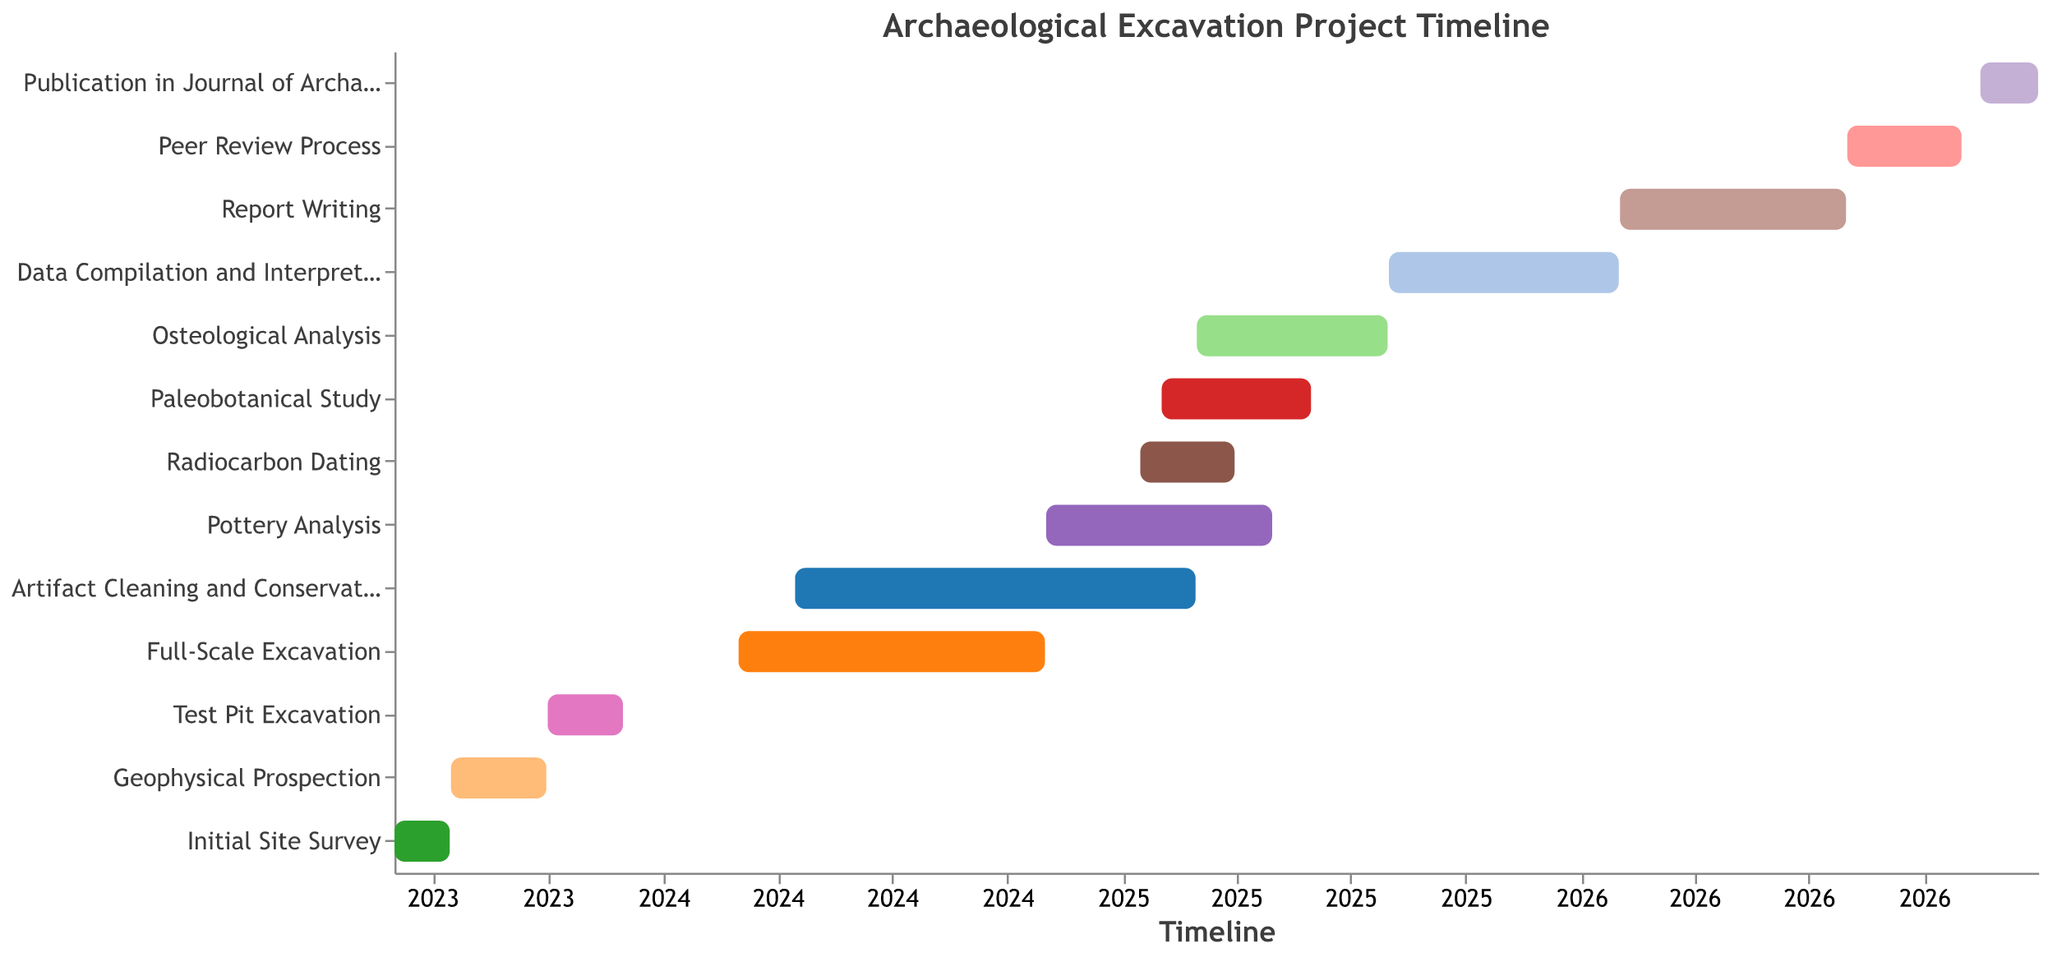What is the duration of the initial site survey? The initial site survey starts on 2023-06-01 and ends on 2023-07-15. The duration is calculated by finding the difference between the end date and the start date.
Answer: 45 days Which task starts immediately after the initial site survey? To determine which task starts right after the initial site survey, we need to look for the task that begins on or around 2023-07-16. That task is "Geophysical Prospection".
Answer: Geophysical Prospection During which months does the full-scale excavation take place? The full-scale excavation starts on 2024-03-01 and ends on 2024-10-31. By examining these dates, we can determine that the excavation spans from March to October 2024.
Answer: March to October 2024 Which tasks overlap with the artifact cleaning and conservation stage? The artifact cleaning and conservation stage runs from 2024-04-15 to 2025-02-28. Tasks that overlap with this period include the full-scale excavation, pottery analysis, radiocarbon dating, and paleobotanical study.
Answer: Full-Scale Excavation, Pottery Analysis, Radiocarbon Dating, Paleobotanical Study How long does the report writing stage last? The report writing stage starts on 2026-02-01 and ends on 2026-07-31. The duration is the difference between these dates.
Answer: 182 days Which task has the shortest duration, and how long does it last? Comparing the durations by subtracting the start date from the end date for each task, the shortest duration is the publication in the Journal of Archaeological Science, lasting from 2026-11-15 to 2026-12-31.
Answer: Publication in Journal of Archaeological Science, 46 days Which tasks are conducted simultaneously in the first quarter of 2025? To find tasks in Q1 2025, we need to look at the dates from 2025-01-01 to 2025-03-31. "Radiocarbon Dating" and "Pottery Analysis" start in this quarter, and "Artifact Cleaning and Conservation" is ongoing during this period.
Answer: Radiocarbon Dating, Pottery Analysis, Artifact Cleaning and Conservation How many tasks are scheduled to start in 2024? By checking the start dates of each task, we find that four tasks start in 2024: Full-Scale Excavation, Artifact Cleaning and Conservation, Pottery Analysis, and Radiocarbon Dating.
Answer: 4 tasks 